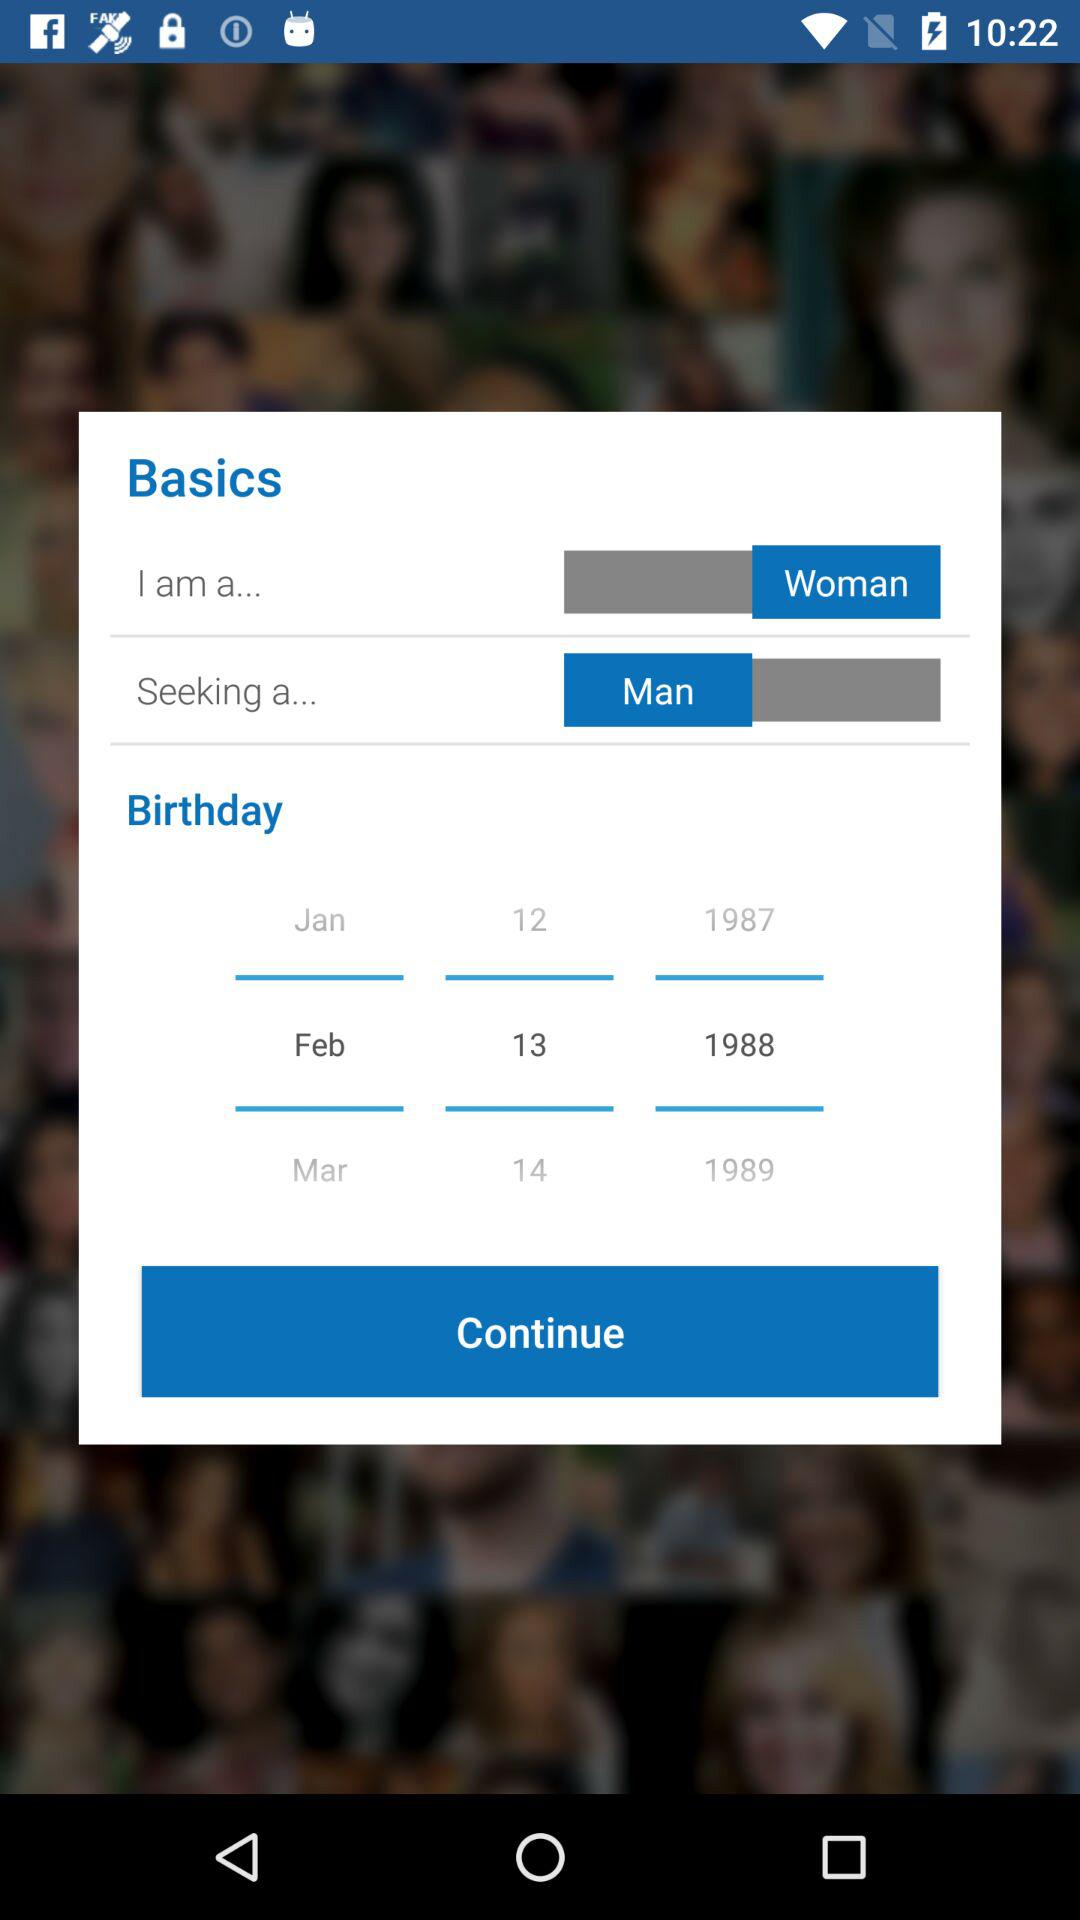What is the selected birthday date? The selected birthday date is February 13, 1988. 